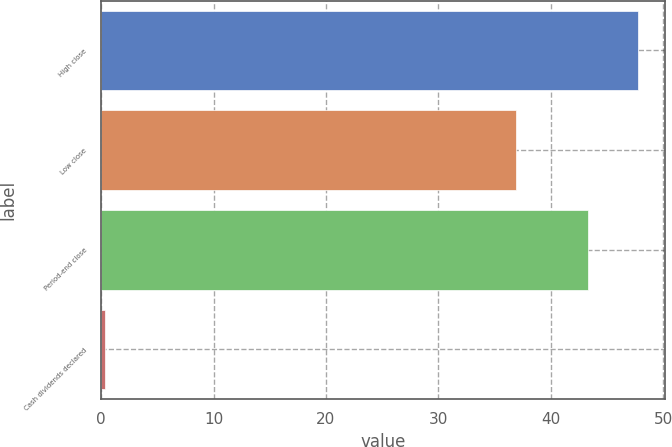Convert chart. <chart><loc_0><loc_0><loc_500><loc_500><bar_chart><fcel>High close<fcel>Low close<fcel>Period-end close<fcel>Cash dividends declared<nl><fcel>47.75<fcel>36.91<fcel>43.31<fcel>0.35<nl></chart> 